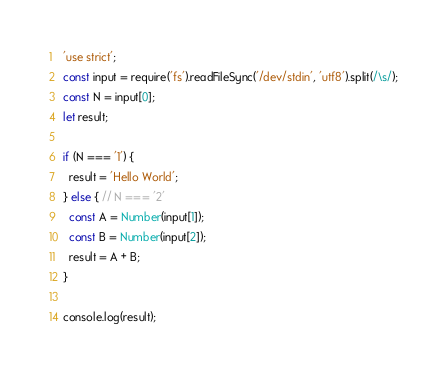Convert code to text. <code><loc_0><loc_0><loc_500><loc_500><_JavaScript_>'use strict';
const input = require('fs').readFileSync('/dev/stdin', 'utf8').split(/\s/);
const N = input[0];
let result;

if (N === '1') {
  result = 'Hello World';
} else { // N === '2'
  const A = Number(input[1]);
  const B = Number(input[2]);
  result = A + B;
}

console.log(result);</code> 